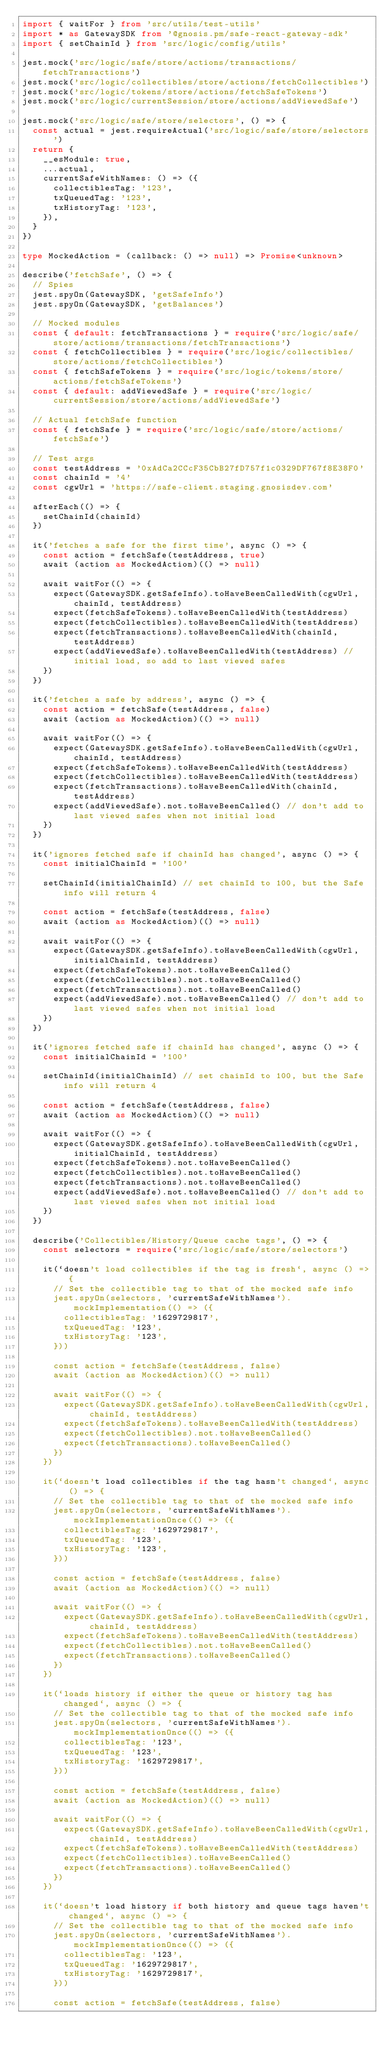<code> <loc_0><loc_0><loc_500><loc_500><_TypeScript_>import { waitFor } from 'src/utils/test-utils'
import * as GatewaySDK from '@gnosis.pm/safe-react-gateway-sdk'
import { setChainId } from 'src/logic/config/utils'

jest.mock('src/logic/safe/store/actions/transactions/fetchTransactions')
jest.mock('src/logic/collectibles/store/actions/fetchCollectibles')
jest.mock('src/logic/tokens/store/actions/fetchSafeTokens')
jest.mock('src/logic/currentSession/store/actions/addViewedSafe')

jest.mock('src/logic/safe/store/selectors', () => {
  const actual = jest.requireActual('src/logic/safe/store/selectors')
  return {
    __esModule: true,
    ...actual,
    currentSafeWithNames: () => ({
      collectiblesTag: '123',
      txQueuedTag: '123',
      txHistoryTag: '123',
    }),
  }
})

type MockedAction = (callback: () => null) => Promise<unknown>

describe('fetchSafe', () => {
  // Spies
  jest.spyOn(GatewaySDK, 'getSafeInfo')
  jest.spyOn(GatewaySDK, 'getBalances')

  // Mocked modules
  const { default: fetchTransactions } = require('src/logic/safe/store/actions/transactions/fetchTransactions')
  const { fetchCollectibles } = require('src/logic/collectibles/store/actions/fetchCollectibles')
  const { fetchSafeTokens } = require('src/logic/tokens/store/actions/fetchSafeTokens')
  const { default: addViewedSafe } = require('src/logic/currentSession/store/actions/addViewedSafe')

  // Actual fetchSafe function
  const { fetchSafe } = require('src/logic/safe/store/actions/fetchSafe')

  // Test args
  const testAddress = '0xAdCa2CCcF35CbB27fD757f1c0329DF767f8E38F0'
  const chainId = '4'
  const cgwUrl = 'https://safe-client.staging.gnosisdev.com'

  afterEach(() => {
    setChainId(chainId)
  })

  it('fetches a safe for the first time', async () => {
    const action = fetchSafe(testAddress, true)
    await (action as MockedAction)(() => null)

    await waitFor(() => {
      expect(GatewaySDK.getSafeInfo).toHaveBeenCalledWith(cgwUrl, chainId, testAddress)
      expect(fetchSafeTokens).toHaveBeenCalledWith(testAddress)
      expect(fetchCollectibles).toHaveBeenCalledWith(testAddress)
      expect(fetchTransactions).toHaveBeenCalledWith(chainId, testAddress)
      expect(addViewedSafe).toHaveBeenCalledWith(testAddress) // initial load, so add to last viewed safes
    })
  })

  it('fetches a safe by address', async () => {
    const action = fetchSafe(testAddress, false)
    await (action as MockedAction)(() => null)

    await waitFor(() => {
      expect(GatewaySDK.getSafeInfo).toHaveBeenCalledWith(cgwUrl, chainId, testAddress)
      expect(fetchSafeTokens).toHaveBeenCalledWith(testAddress)
      expect(fetchCollectibles).toHaveBeenCalledWith(testAddress)
      expect(fetchTransactions).toHaveBeenCalledWith(chainId, testAddress)
      expect(addViewedSafe).not.toHaveBeenCalled() // don't add to last viewed safes when not initial load
    })
  })

  it('ignores fetched safe if chainId has changed', async () => {
    const initialChainId = '100'

    setChainId(initialChainId) // set chainId to 100, but the Safe info will return 4

    const action = fetchSafe(testAddress, false)
    await (action as MockedAction)(() => null)

    await waitFor(() => {
      expect(GatewaySDK.getSafeInfo).toHaveBeenCalledWith(cgwUrl, initialChainId, testAddress)
      expect(fetchSafeTokens).not.toHaveBeenCalled()
      expect(fetchCollectibles).not.toHaveBeenCalled()
      expect(fetchTransactions).not.toHaveBeenCalled()
      expect(addViewedSafe).not.toHaveBeenCalled() // don't add to last viewed safes when not initial load
    })
  })

  it('ignores fetched safe if chainId has changed', async () => {
    const initialChainId = '100'

    setChainId(initialChainId) // set chainId to 100, but the Safe info will return 4

    const action = fetchSafe(testAddress, false)
    await (action as MockedAction)(() => null)

    await waitFor(() => {
      expect(GatewaySDK.getSafeInfo).toHaveBeenCalledWith(cgwUrl, initialChainId, testAddress)
      expect(fetchSafeTokens).not.toHaveBeenCalled()
      expect(fetchCollectibles).not.toHaveBeenCalled()
      expect(fetchTransactions).not.toHaveBeenCalled()
      expect(addViewedSafe).not.toHaveBeenCalled() // don't add to last viewed safes when not initial load
    })
  })

  describe('Collectibles/History/Queue cache tags', () => {
    const selectors = require('src/logic/safe/store/selectors')

    it(`doesn't load collectibles if the tag is fresh`, async () => {
      // Set the collectible tag to that of the mocked safe info
      jest.spyOn(selectors, 'currentSafeWithNames').mockImplementation(() => ({
        collectiblesTag: '1629729817',
        txQueuedTag: '123',
        txHistoryTag: '123',
      }))

      const action = fetchSafe(testAddress, false)
      await (action as MockedAction)(() => null)

      await waitFor(() => {
        expect(GatewaySDK.getSafeInfo).toHaveBeenCalledWith(cgwUrl, chainId, testAddress)
        expect(fetchSafeTokens).toHaveBeenCalledWith(testAddress)
        expect(fetchCollectibles).not.toHaveBeenCalled()
        expect(fetchTransactions).toHaveBeenCalled()
      })
    })

    it(`doesn't load collectibles if the tag hasn't changed`, async () => {
      // Set the collectible tag to that of the mocked safe info
      jest.spyOn(selectors, 'currentSafeWithNames').mockImplementationOnce(() => ({
        collectiblesTag: '1629729817',
        txQueuedTag: '123',
        txHistoryTag: '123',
      }))

      const action = fetchSafe(testAddress, false)
      await (action as MockedAction)(() => null)

      await waitFor(() => {
        expect(GatewaySDK.getSafeInfo).toHaveBeenCalledWith(cgwUrl, chainId, testAddress)
        expect(fetchSafeTokens).toHaveBeenCalledWith(testAddress)
        expect(fetchCollectibles).not.toHaveBeenCalled()
        expect(fetchTransactions).toHaveBeenCalled()
      })
    })

    it(`loads history if either the queue or history tag has changed`, async () => {
      // Set the collectible tag to that of the mocked safe info
      jest.spyOn(selectors, 'currentSafeWithNames').mockImplementationOnce(() => ({
        collectiblesTag: '123',
        txQueuedTag: '123',
        txHistoryTag: '1629729817',
      }))

      const action = fetchSafe(testAddress, false)
      await (action as MockedAction)(() => null)

      await waitFor(() => {
        expect(GatewaySDK.getSafeInfo).toHaveBeenCalledWith(cgwUrl, chainId, testAddress)
        expect(fetchSafeTokens).toHaveBeenCalledWith(testAddress)
        expect(fetchCollectibles).toHaveBeenCalled()
        expect(fetchTransactions).toHaveBeenCalled()
      })
    })

    it(`doesn't load history if both history and queue tags haven't changed`, async () => {
      // Set the collectible tag to that of the mocked safe info
      jest.spyOn(selectors, 'currentSafeWithNames').mockImplementationOnce(() => ({
        collectiblesTag: '123',
        txQueuedTag: '1629729817',
        txHistoryTag: '1629729817',
      }))

      const action = fetchSafe(testAddress, false)</code> 